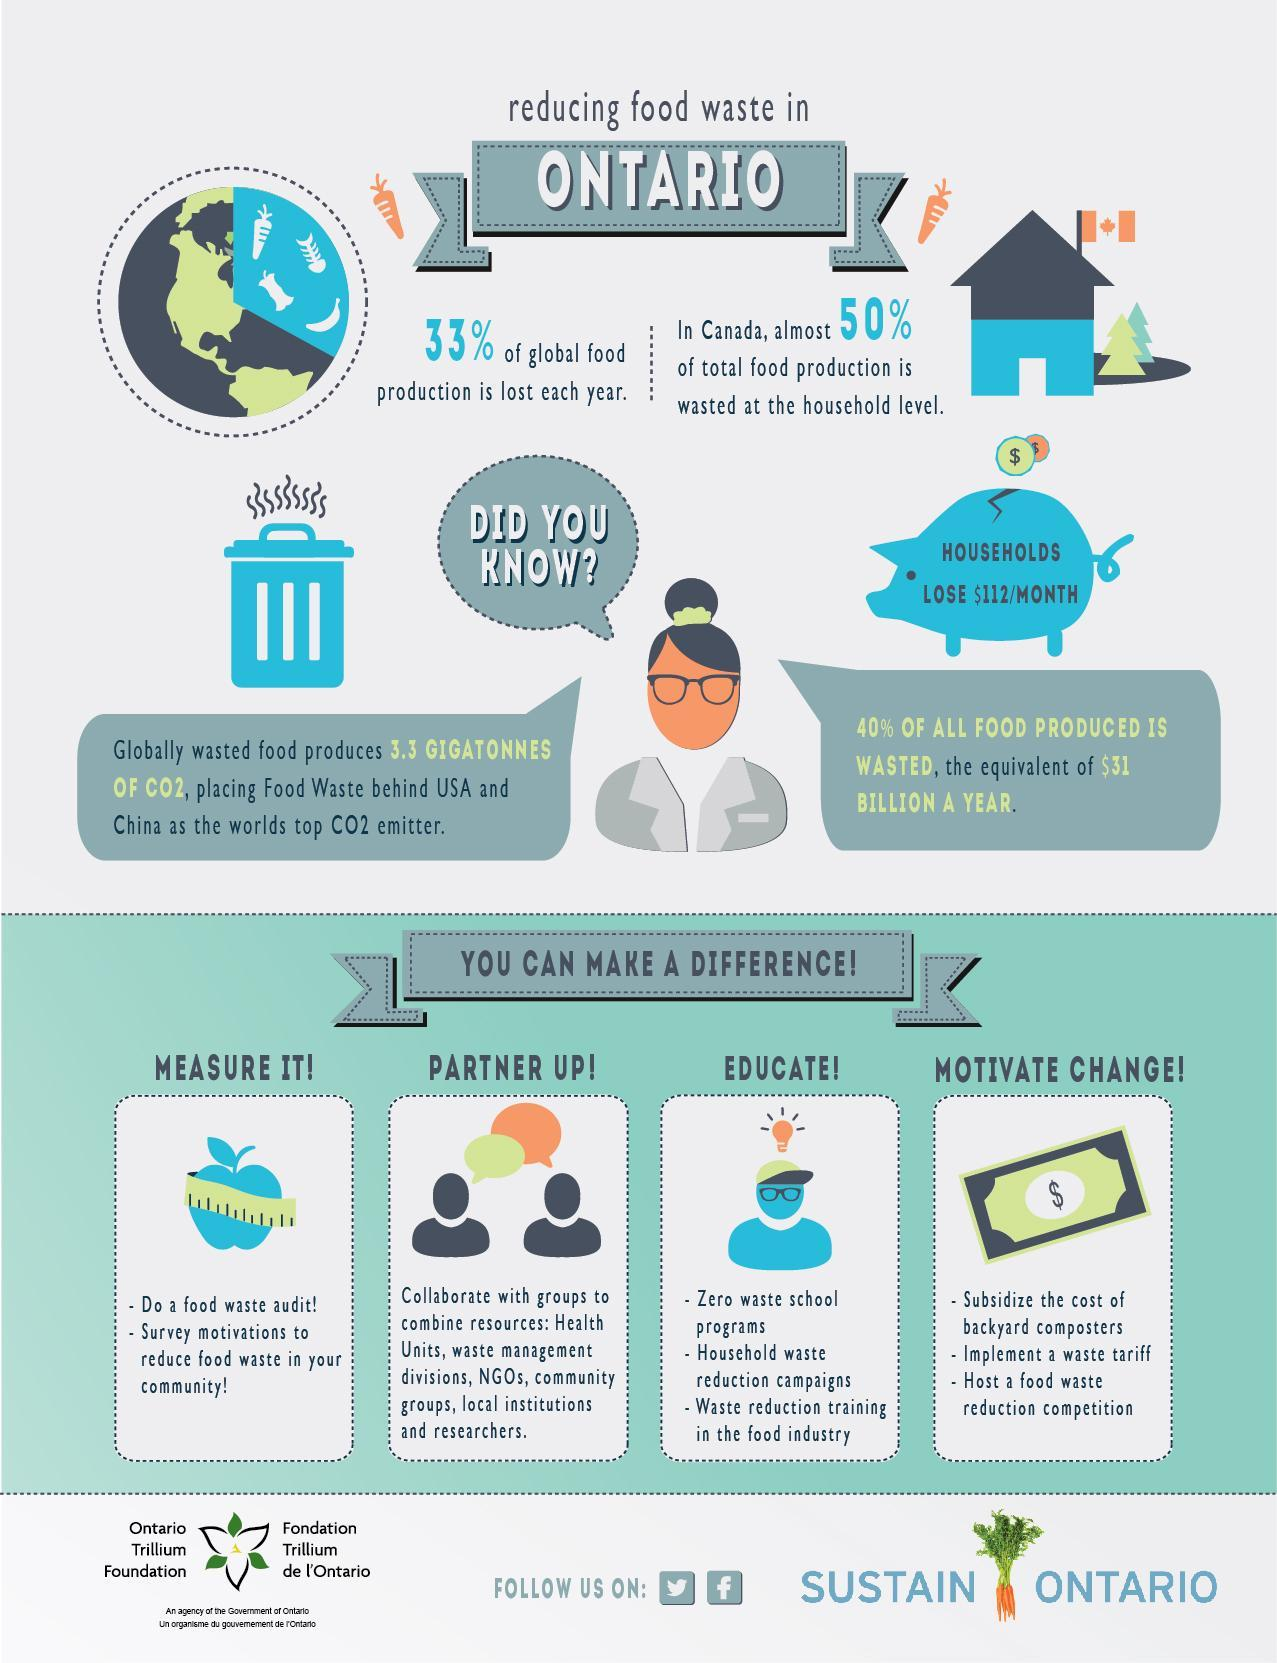What percentage of the entire food production is wasted by the Canadian households?
Answer the question with a short phrase. 50% How many ways to make a difference are mentioned here? 4 What are the first three ways to 'make a difference' mentioned here? Measure it!, Partner up!, Educate! What is the estimated value (in dollars) of food wasted each year? 31 billion Name the top 2 carbon dioxide emitters in the world? USA, China What competition can be hosted to motivate change? Food waste reduction competition From the four ways to make a difference mentioned here, which one is represented by the image of a dollar note? Motivate change! What percent of global food production is not wasted each year? 77% What programs can be introduced to students to educate them about food waste management? Zero waste School programs What quantity of carbon dioxide is emitted from food waste? 3.3 gigatonnes 